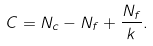Convert formula to latex. <formula><loc_0><loc_0><loc_500><loc_500>C = N _ { c } - N _ { f } + \frac { N _ { f } } { k } .</formula> 